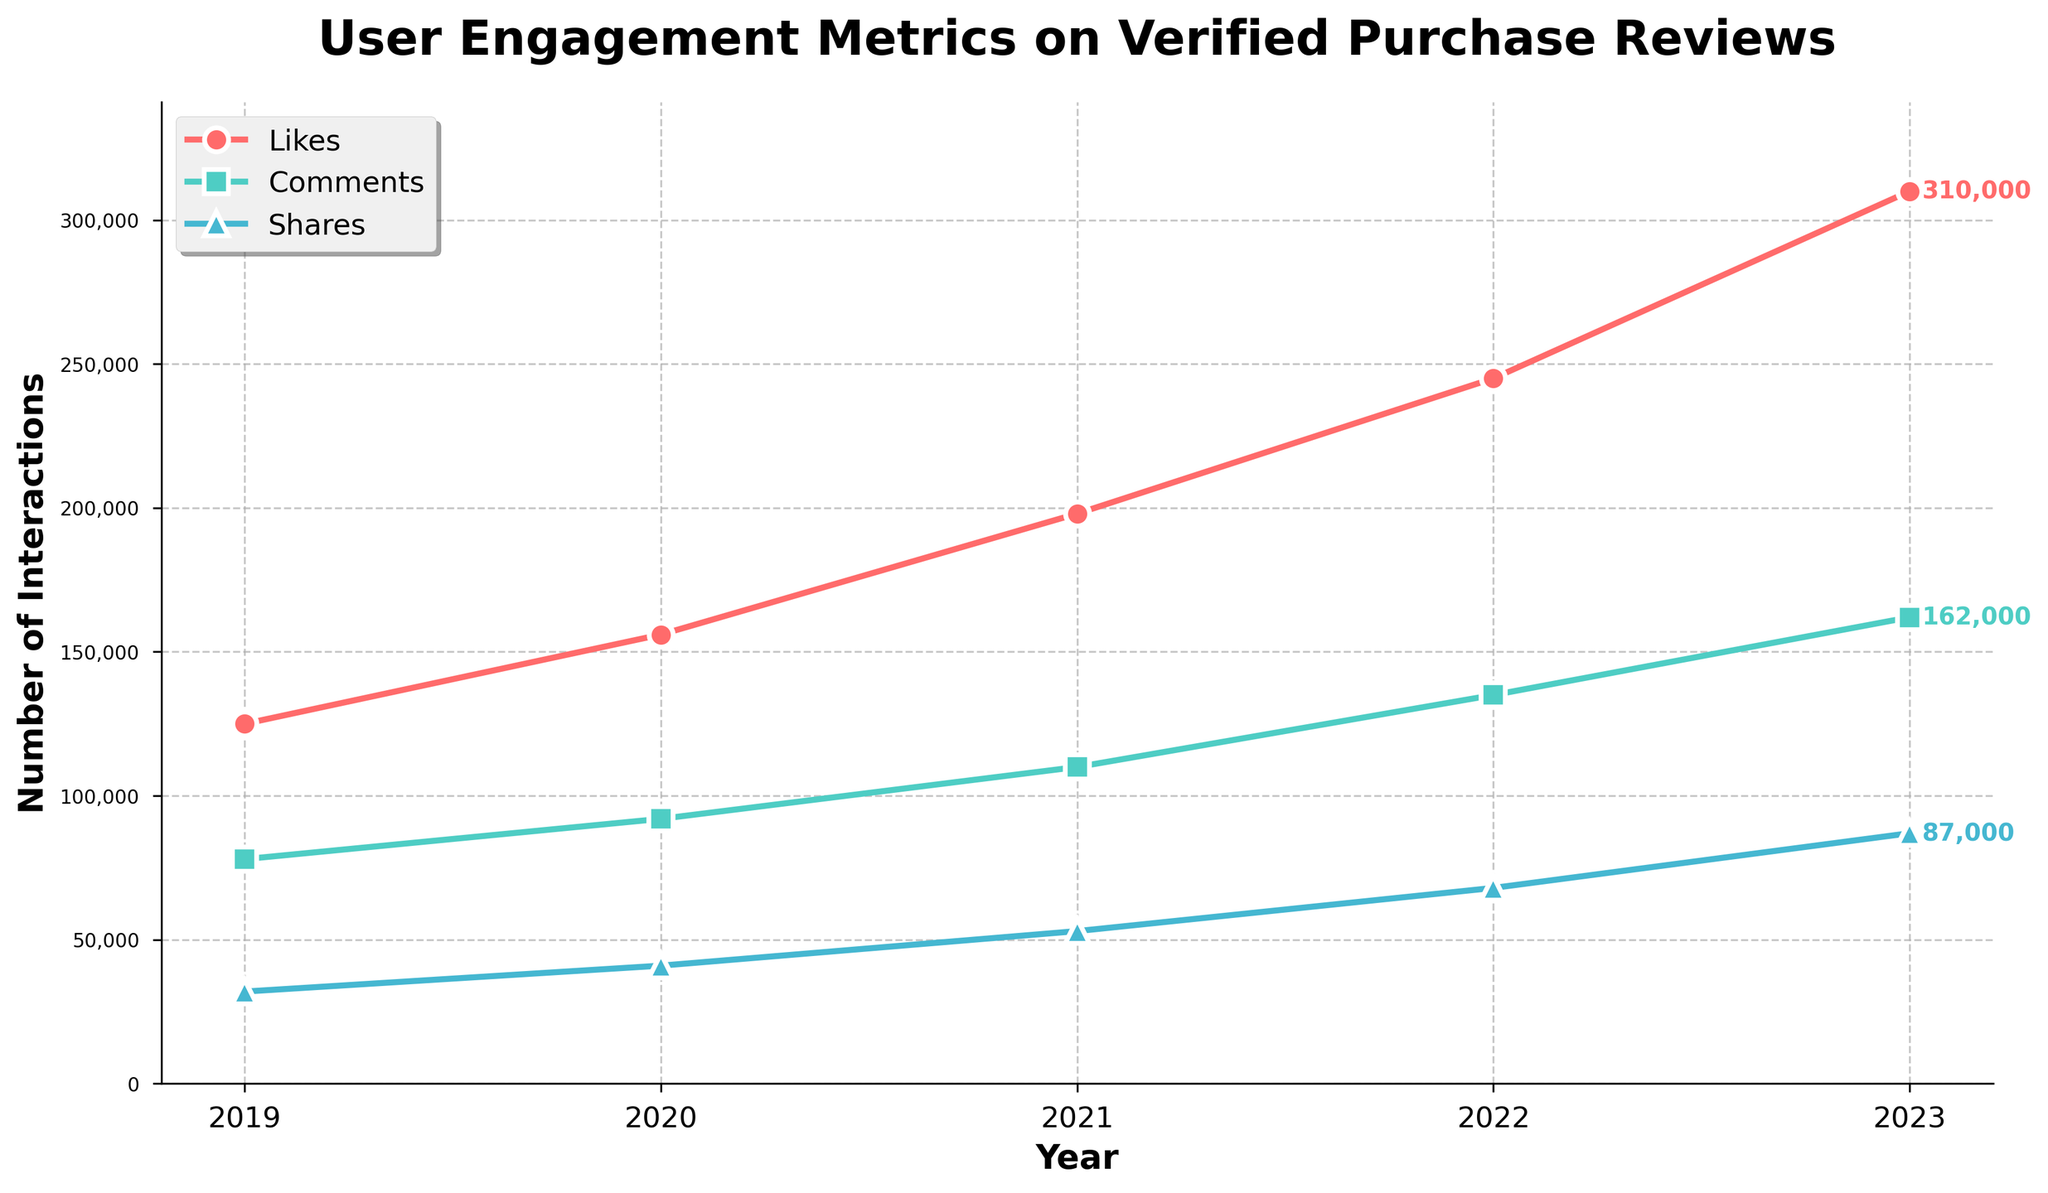How many more Likes were there in 2023 compared to 2019? Find the number of Likes in 2023 and in 2019 from the figure. Subtract the number of Likes in 2019 from that in 2023: 310,000 - 125,000 = 185,000
Answer: 185,000 What is the trend in the number of Shares from 2019 to 2023? Observe the direction in which the Share values change over the years from the figure. Shares increased every year: 32,000, 41,000, 53,000, 68,000, 87,000
Answer: Increasing By how much did the number of Comments increase from 2021 to 2022? Find the number of Comments in 2021 and in 2022 from the figure. Subtract the number of Comments in 2021 from that in 2022: 135,000 - 110,000 = 25,000
Answer: 25,000 In which year did Likes see the highest growth compared to the previous year? Calculate the yearly growth in Likes by subtracting the number of Likes in the previous year from the current year's Likes. The highest growth is between 2022 and 2023: 310,000 - 245,000 = 65,000
Answer: 2023 Which engagement metric had the largest increase from 2019 to 2023? Calculate the increase for each metric by subtracting the 2019 value from the 2023 value. Likes: 310,000 - 125,000 = 185,000, Comments: 162,000 - 78,000 = 84,000, Shares: 87,000 - 32,000 = 55,000. Likes had the largest increase.
Answer: Likes In 2020, was the number of Comments higher or lower than the number of Likes in 2019? Find the number of Comments in 2020 and the number of Likes in 2019 from the figure. Compare the two values: 92,000 (Comments in 2020) > 125,000 (Likes in 2019)
Answer: Higher What is the total number of Comments across all five years? Sum up the number of Comments for each year: 78,000 + 92,000 + 110,000 + 135,000 + 162,000 = 577,000
Answer: 577,000 What is the average number of Shares per year from 2019 to 2023? Sum up the number of Shares for each year and then divide by the number of years: (32,000 + 41,000 + 53,000 + 68,000 + 87,000) / 5 = 56,200
Answer: 56,200 In which year did the number of Comments first exceed 100,000? Check the number of Comments for each year and find the first year where the count exceeds 100,000. The number of Comments in 2021 is 110,000
Answer: 2021 By how much did the total number of Likes and Shares increase from 2019 to 2023? First, calculate the increase in Likes and Shares separately: Likes: 310,000 - 125,000 = 185,000; Shares: 87,000 - 32,000 = 55,000. Then sum these increases: 185,000 + 55,000 = 240,000
Answer: 240,000 